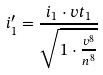Convert formula to latex. <formula><loc_0><loc_0><loc_500><loc_500>i _ { 1 } ^ { \prime } = \frac { i _ { 1 } \cdot v t _ { 1 } } { \sqrt { 1 \cdot \frac { v ^ { 8 } } { n ^ { 8 } } } }</formula> 